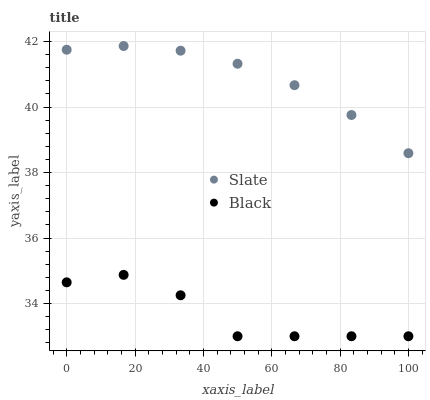Does Black have the minimum area under the curve?
Answer yes or no. Yes. Does Slate have the maximum area under the curve?
Answer yes or no. Yes. Does Black have the maximum area under the curve?
Answer yes or no. No. Is Slate the smoothest?
Answer yes or no. Yes. Is Black the roughest?
Answer yes or no. Yes. Is Black the smoothest?
Answer yes or no. No. Does Black have the lowest value?
Answer yes or no. Yes. Does Slate have the highest value?
Answer yes or no. Yes. Does Black have the highest value?
Answer yes or no. No. Is Black less than Slate?
Answer yes or no. Yes. Is Slate greater than Black?
Answer yes or no. Yes. Does Black intersect Slate?
Answer yes or no. No. 